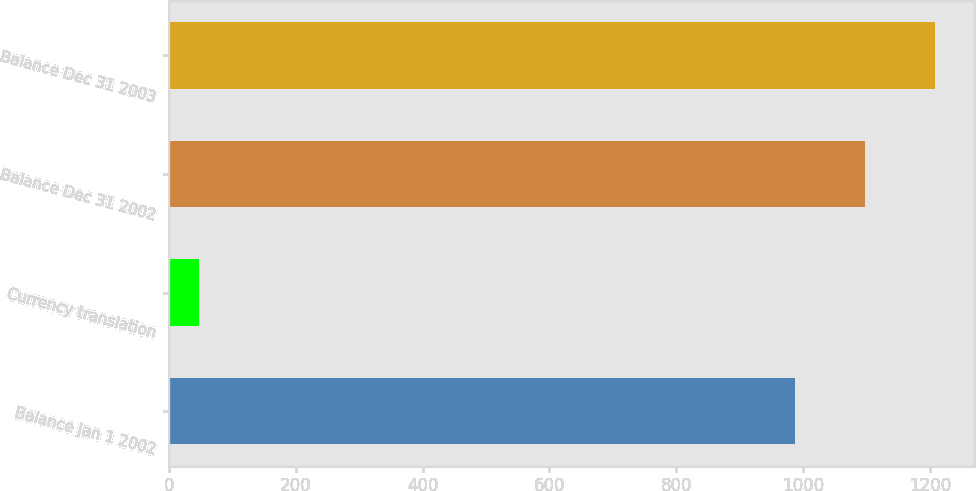Convert chart to OTSL. <chart><loc_0><loc_0><loc_500><loc_500><bar_chart><fcel>Balance Jan 1 2002<fcel>Currency translation<fcel>Balance Dec 31 2002<fcel>Balance Dec 31 2003<nl><fcel>987<fcel>48<fcel>1097.9<fcel>1208.8<nl></chart> 